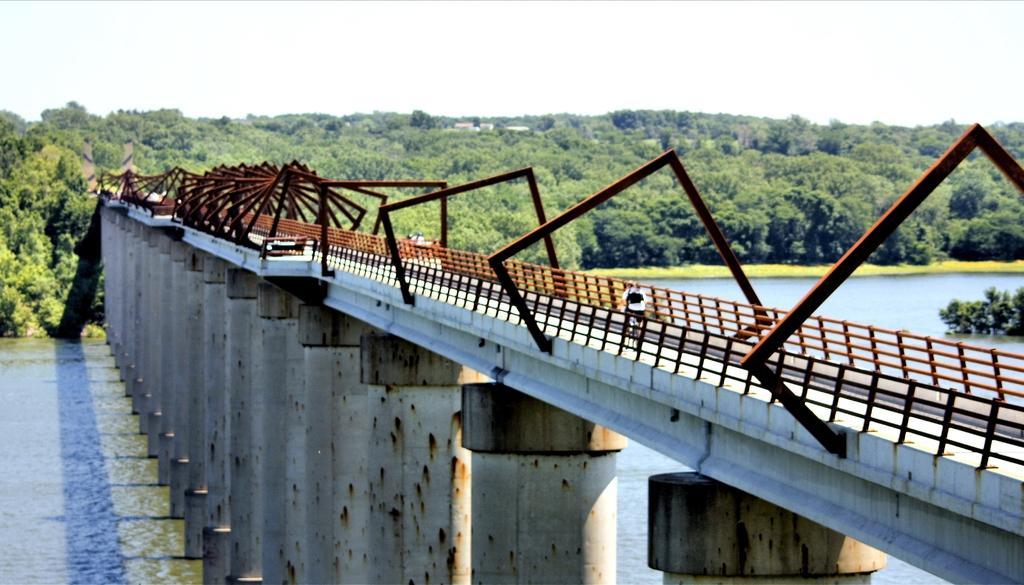Please provide a concise description of this image. In this image in the center there is a bridge and railing, at the bottom there is a river and pillars. In the background there are trees and some buildings, and on the bridge there is one person sitting on a cycle. 